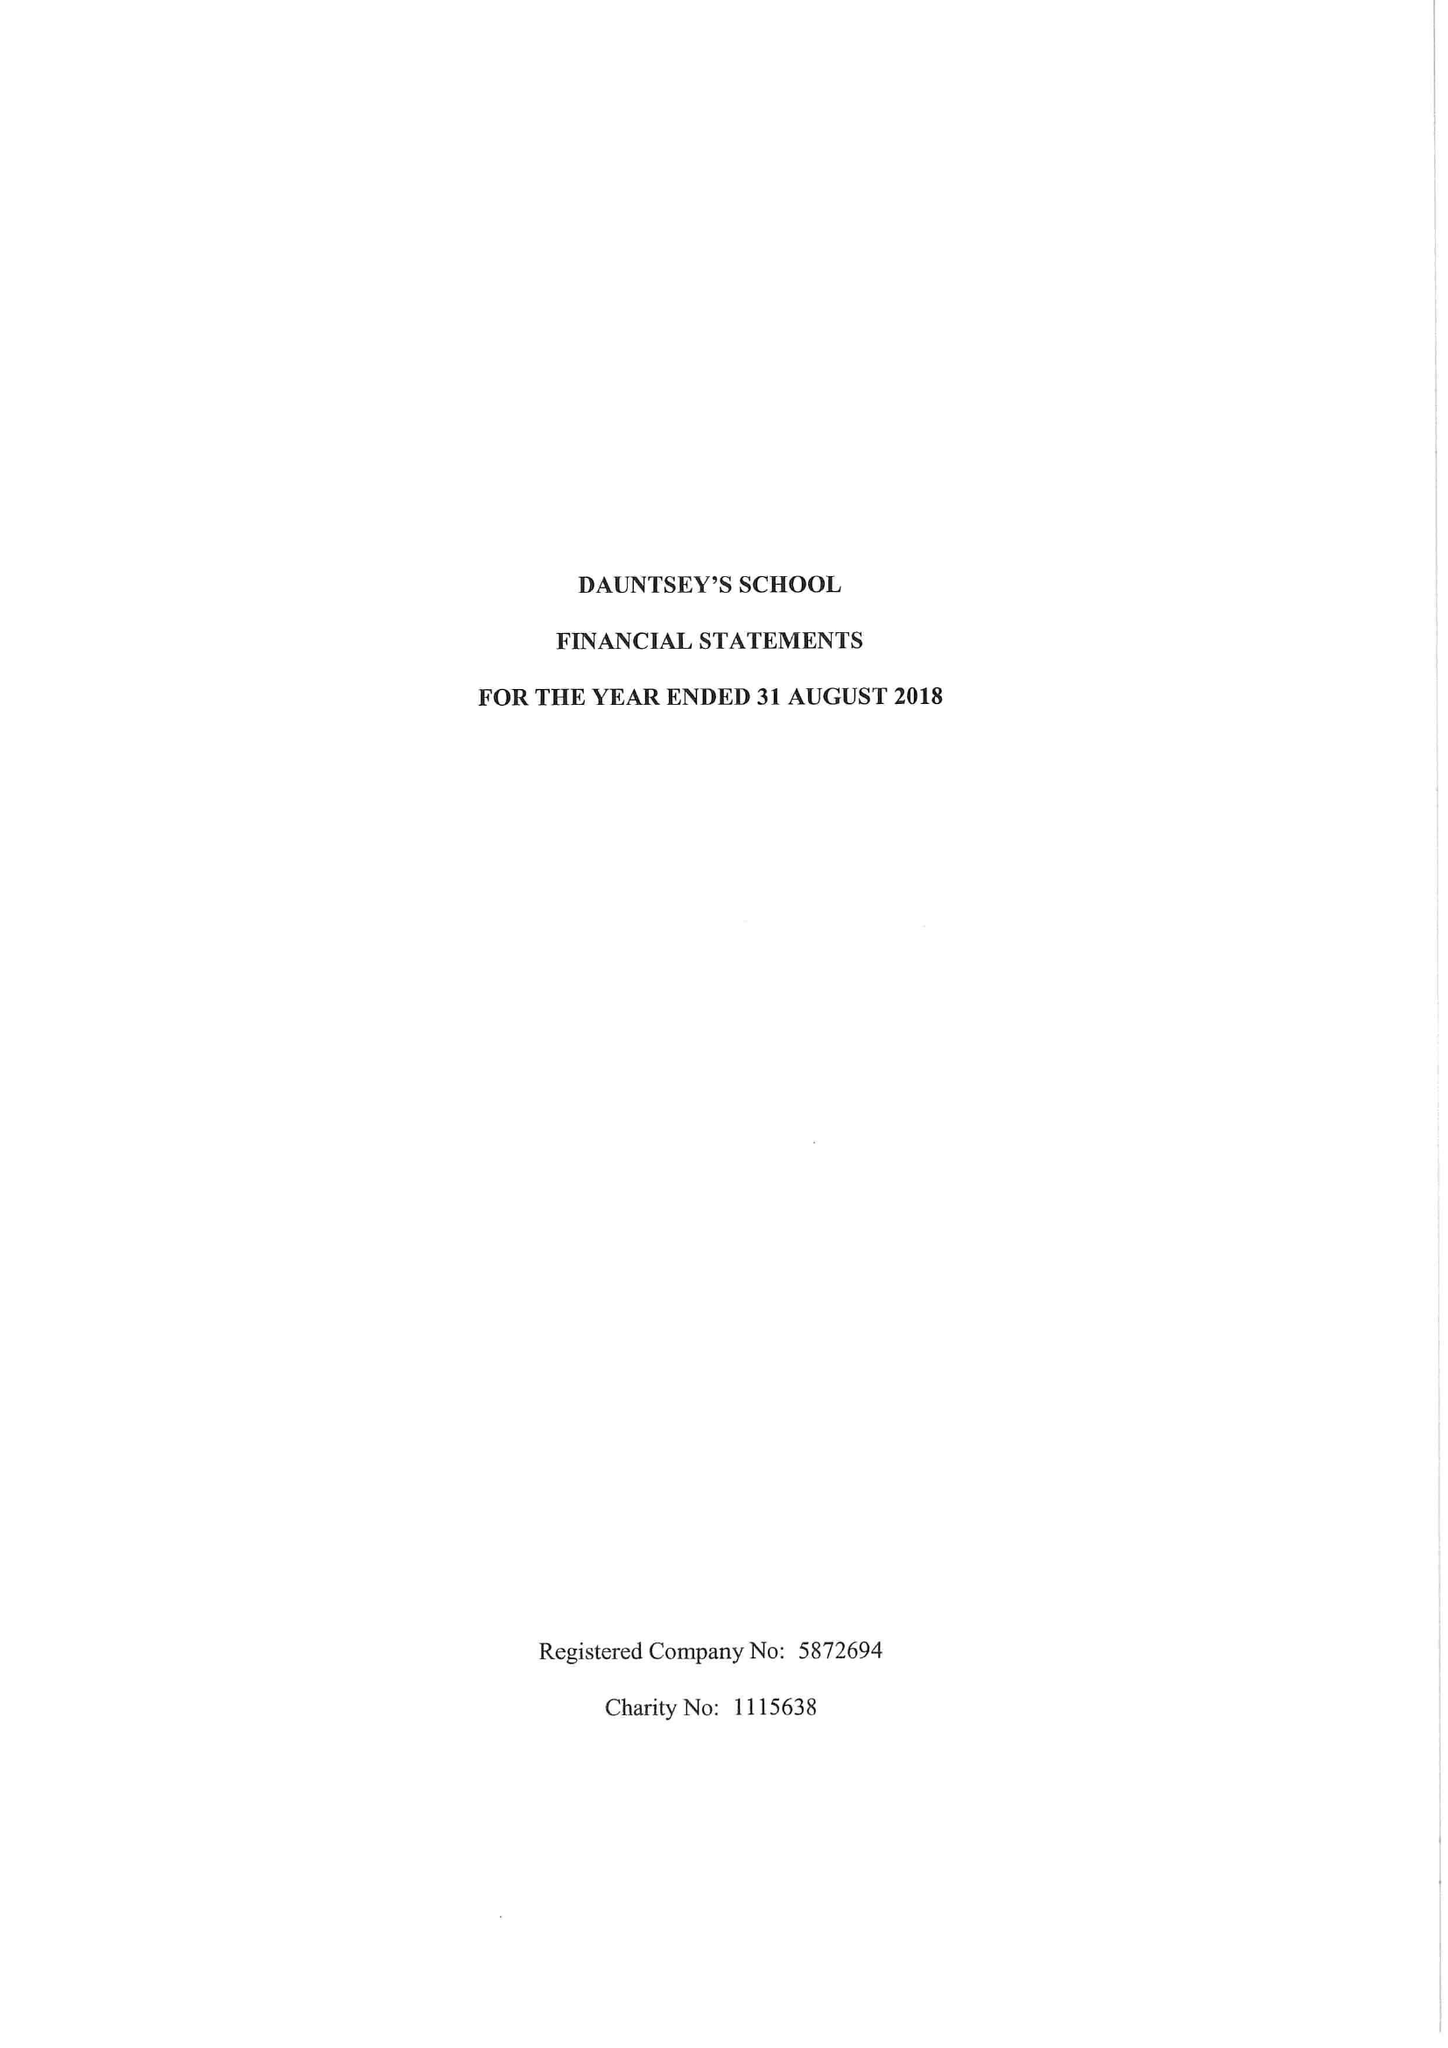What is the value for the address__street_line?
Answer the question using a single word or phrase. HIGH STREET 